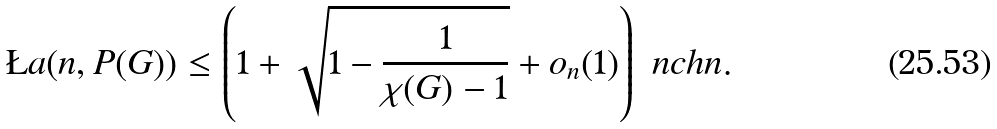Convert formula to latex. <formula><loc_0><loc_0><loc_500><loc_500>\L a ( n , P ( G ) ) \leq \left ( 1 + \sqrt { 1 - \frac { 1 } { \chi ( G ) - 1 } } + o _ { n } ( 1 ) \right ) { \ n c h n } .</formula> 